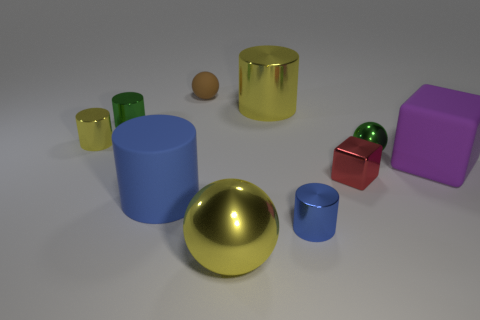Is the number of brown rubber objects that are right of the brown matte ball less than the number of tiny brown matte things that are left of the blue metal thing?
Provide a succinct answer. Yes. There is a red cube; does it have the same size as the yellow cylinder on the right side of the tiny brown matte sphere?
Keep it short and to the point. No. There is a matte thing that is on the left side of the tiny blue thing and behind the rubber cylinder; what is its shape?
Make the answer very short. Sphere. What is the size of the cube that is made of the same material as the big ball?
Offer a terse response. Small. What number of things are behind the small yellow shiny cylinder that is to the left of the brown object?
Your answer should be very brief. 3. Are the green thing that is behind the green metal ball and the tiny blue thing made of the same material?
Your answer should be compact. Yes. Is there any other thing that is the same material as the green sphere?
Make the answer very short. Yes. What size is the yellow cylinder on the right side of the small green thing that is left of the green metal sphere?
Your answer should be very brief. Large. There is a yellow cylinder right of the big yellow object left of the big cylinder that is behind the purple cube; what is its size?
Provide a succinct answer. Large. There is a large rubber thing that is in front of the purple block; is its shape the same as the large thing in front of the large blue rubber object?
Offer a very short reply. No. 